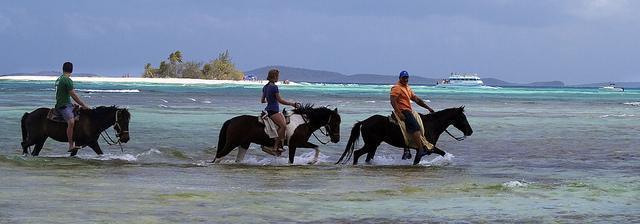What is the terrain with trees on it?
Choose the correct response and explain in the format: 'Answer: answer
Rationale: rationale.'
Options: Savanna, private island, peninsula, plain. Answer: private island.
Rationale: It is an island because it has water all around it. 